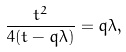<formula> <loc_0><loc_0><loc_500><loc_500>\frac { t ^ { 2 } } { 4 ( t - q \lambda ) } = q \lambda ,</formula> 